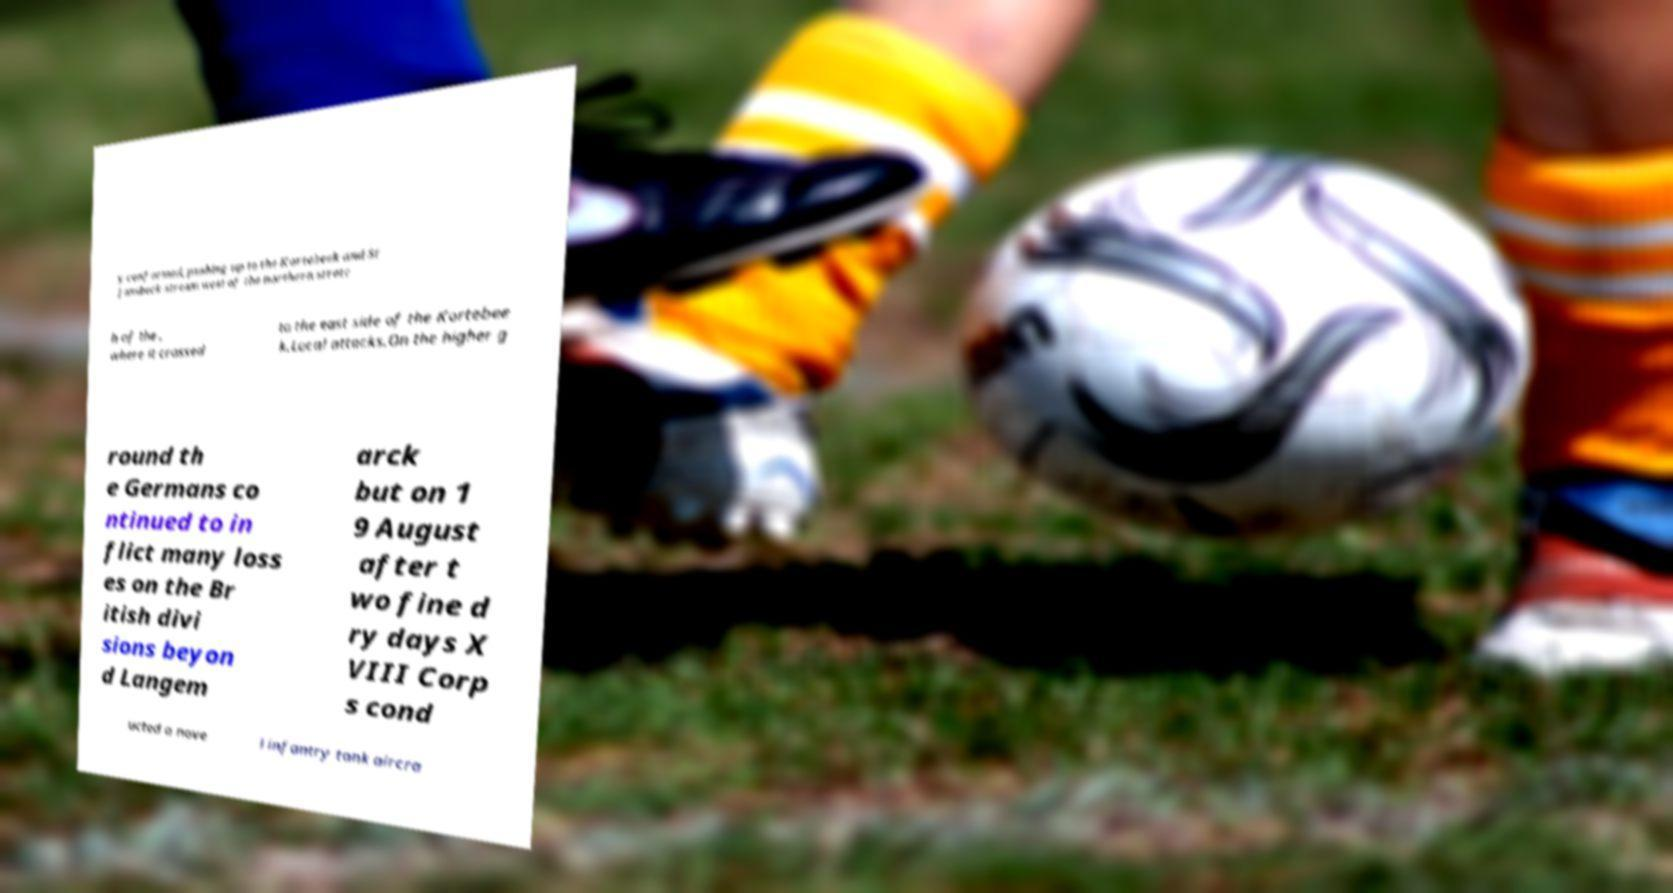What messages or text are displayed in this image? I need them in a readable, typed format. y conformed, pushing up to the Kortebeek and St Jansbeck stream west of the northern stretc h of the , where it crossed to the east side of the Kortebee k.Local attacks.On the higher g round th e Germans co ntinued to in flict many loss es on the Br itish divi sions beyon d Langem arck but on 1 9 August after t wo fine d ry days X VIII Corp s cond ucted a nove l infantry tank aircra 